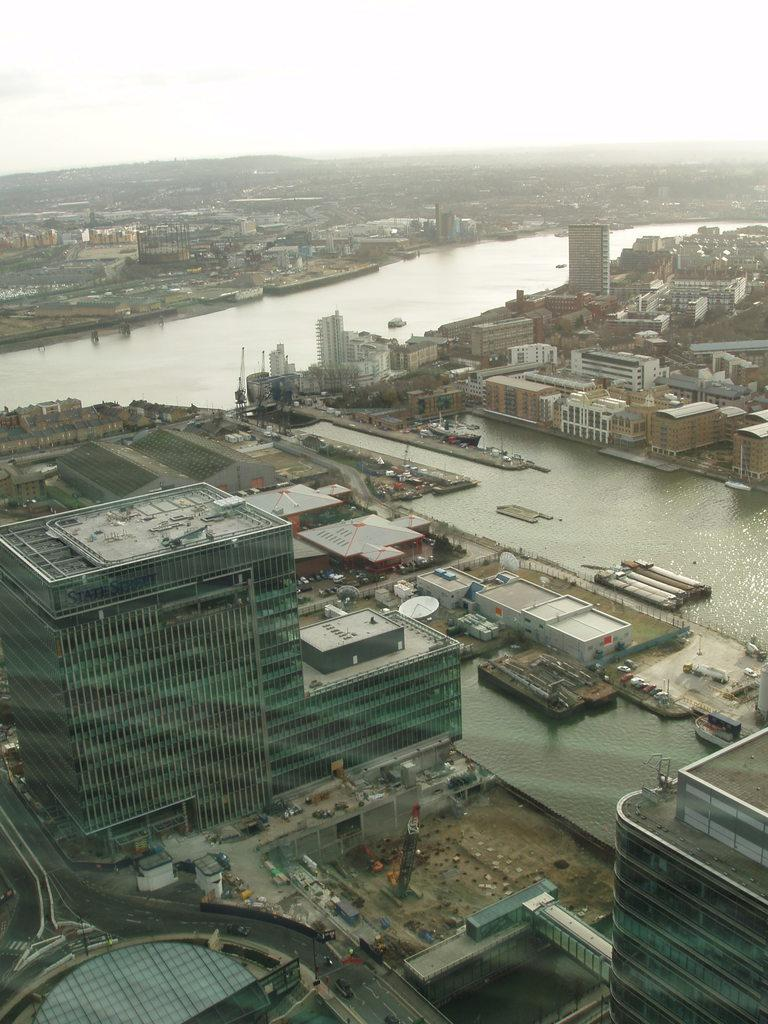What type of structures can be seen in the image? There are buildings in the image. What else is present in the image besides buildings? There are vehicles and water visible in the image. Can you describe the objects in the image? Yes, there are objects present in the image. What part of the natural environment is visible in the image? The sky is visible in the image. What type of jelly is being used to hold the buildings together in the image? There is no jelly present in the image, and the buildings are not being held together by any such substance. Can you tell me how many mothers are visible in the image? There is no mention of a mother or any people in the image; it primarily features buildings, vehicles, water, objects, and the sky. 